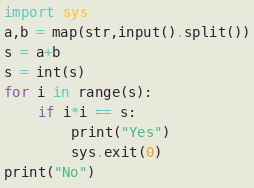<code> <loc_0><loc_0><loc_500><loc_500><_Python_>import sys
a,b = map(str,input().split())
s = a+b
s = int(s)
for i in range(s):
    if i*i == s:
        print("Yes")
        sys.exit(0)
print("No")</code> 